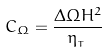Convert formula to latex. <formula><loc_0><loc_0><loc_500><loc_500>C _ { \Omega } = \frac { \Delta \Omega H ^ { 2 } } { \eta _ { _ { T } } }</formula> 